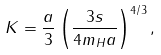Convert formula to latex. <formula><loc_0><loc_0><loc_500><loc_500>K = \frac { a } { 3 } \left ( \frac { 3 s } { 4 m _ { H } a } \right ) ^ { 4 / 3 } ,</formula> 